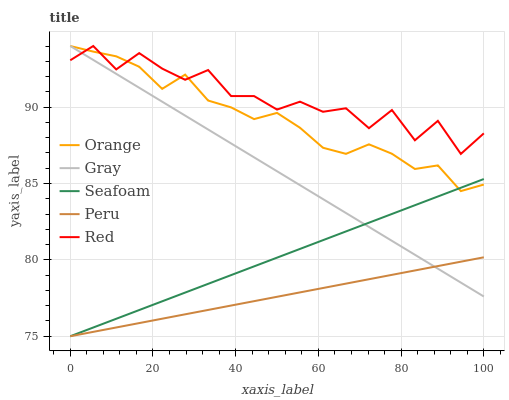Does Peru have the minimum area under the curve?
Answer yes or no. Yes. Does Red have the maximum area under the curve?
Answer yes or no. Yes. Does Gray have the minimum area under the curve?
Answer yes or no. No. Does Gray have the maximum area under the curve?
Answer yes or no. No. Is Peru the smoothest?
Answer yes or no. Yes. Is Red the roughest?
Answer yes or no. Yes. Is Gray the smoothest?
Answer yes or no. No. Is Gray the roughest?
Answer yes or no. No. Does Seafoam have the lowest value?
Answer yes or no. Yes. Does Gray have the lowest value?
Answer yes or no. No. Does Red have the highest value?
Answer yes or no. Yes. Does Seafoam have the highest value?
Answer yes or no. No. Is Seafoam less than Red?
Answer yes or no. Yes. Is Red greater than Seafoam?
Answer yes or no. Yes. Does Seafoam intersect Gray?
Answer yes or no. Yes. Is Seafoam less than Gray?
Answer yes or no. No. Is Seafoam greater than Gray?
Answer yes or no. No. Does Seafoam intersect Red?
Answer yes or no. No. 